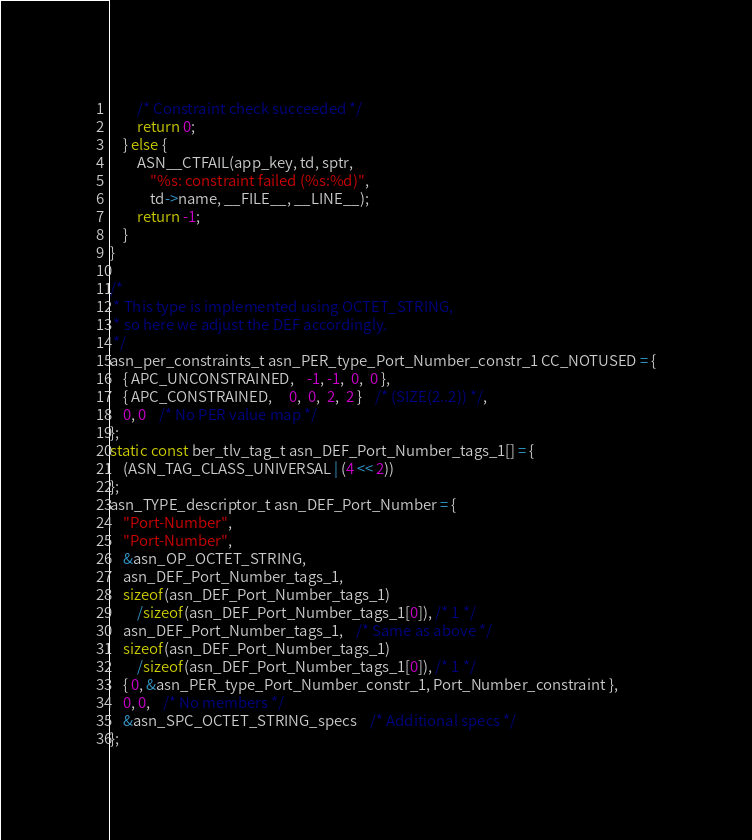<code> <loc_0><loc_0><loc_500><loc_500><_C_>		/* Constraint check succeeded */
		return 0;
	} else {
		ASN__CTFAIL(app_key, td, sptr,
			"%s: constraint failed (%s:%d)",
			td->name, __FILE__, __LINE__);
		return -1;
	}
}

/*
 * This type is implemented using OCTET_STRING,
 * so here we adjust the DEF accordingly.
 */
asn_per_constraints_t asn_PER_type_Port_Number_constr_1 CC_NOTUSED = {
	{ APC_UNCONSTRAINED,	-1, -1,  0,  0 },
	{ APC_CONSTRAINED,	 0,  0,  2,  2 }	/* (SIZE(2..2)) */,
	0, 0	/* No PER value map */
};
static const ber_tlv_tag_t asn_DEF_Port_Number_tags_1[] = {
	(ASN_TAG_CLASS_UNIVERSAL | (4 << 2))
};
asn_TYPE_descriptor_t asn_DEF_Port_Number = {
	"Port-Number",
	"Port-Number",
	&asn_OP_OCTET_STRING,
	asn_DEF_Port_Number_tags_1,
	sizeof(asn_DEF_Port_Number_tags_1)
		/sizeof(asn_DEF_Port_Number_tags_1[0]), /* 1 */
	asn_DEF_Port_Number_tags_1,	/* Same as above */
	sizeof(asn_DEF_Port_Number_tags_1)
		/sizeof(asn_DEF_Port_Number_tags_1[0]), /* 1 */
	{ 0, &asn_PER_type_Port_Number_constr_1, Port_Number_constraint },
	0, 0,	/* No members */
	&asn_SPC_OCTET_STRING_specs	/* Additional specs */
};

</code> 